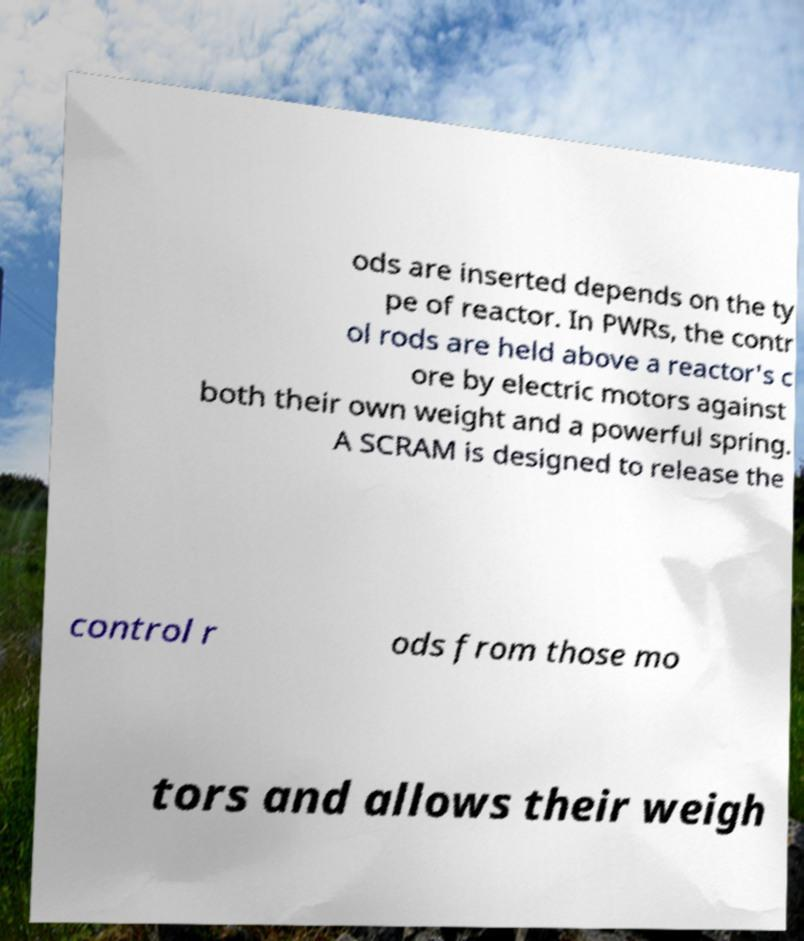Could you extract and type out the text from this image? ods are inserted depends on the ty pe of reactor. In PWRs, the contr ol rods are held above a reactor's c ore by electric motors against both their own weight and a powerful spring. A SCRAM is designed to release the control r ods from those mo tors and allows their weigh 